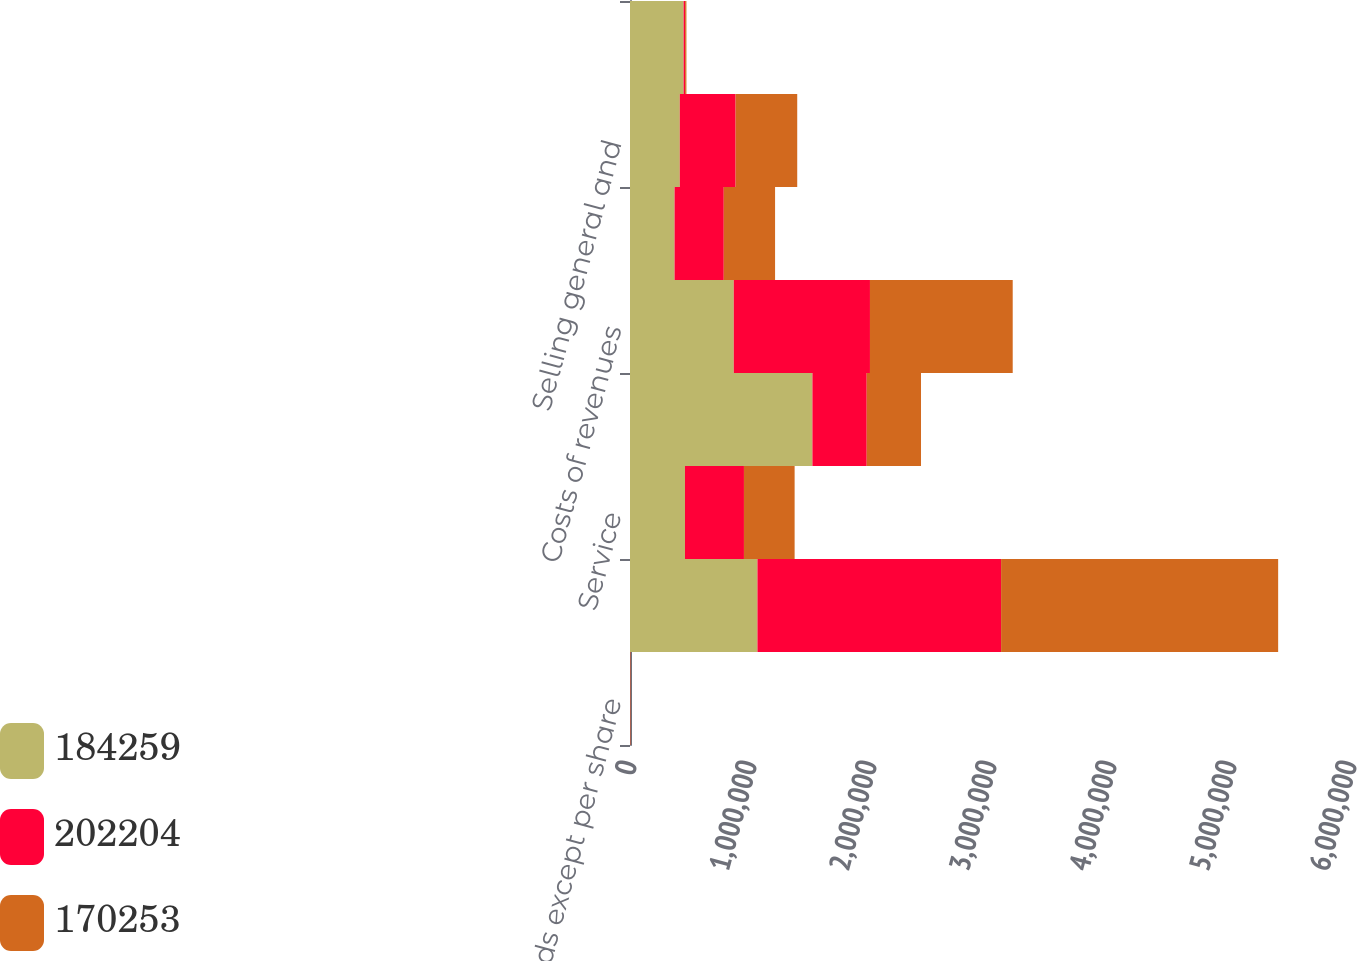Convert chart to OTSL. <chart><loc_0><loc_0><loc_500><loc_500><stacked_bar_chart><ecel><fcel>(In thousands except per share<fcel>Product<fcel>Service<fcel>Total revenues<fcel>Costs of revenues<fcel>Engineering research and<fcel>Selling general and<fcel>Goodwill and purchased<nl><fcel>184259<fcel>2009<fcel>1.06213e+06<fcel>458090<fcel>1.52022e+06<fcel>864824<fcel>371463<fcel>415126<fcel>446744<nl><fcel>202204<fcel>2008<fcel>2.03022e+06<fcel>491492<fcel>452417<fcel>1.13486e+06<fcel>409973<fcel>464890<fcel>12621<nl><fcel>170253<fcel>2007<fcel>2.30894e+06<fcel>422287<fcel>452417<fcel>1.1896e+06<fcel>427515<fcel>513525<fcel>10720<nl></chart> 